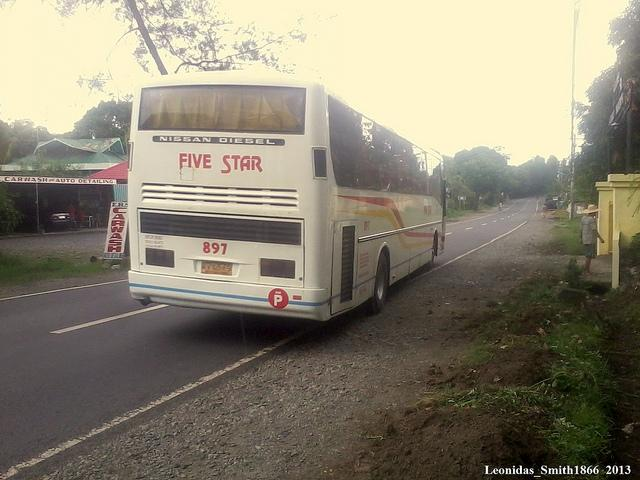The D word here refers to what?

Choices:
A) route
B) brand
C) location
D) fuel fuel 